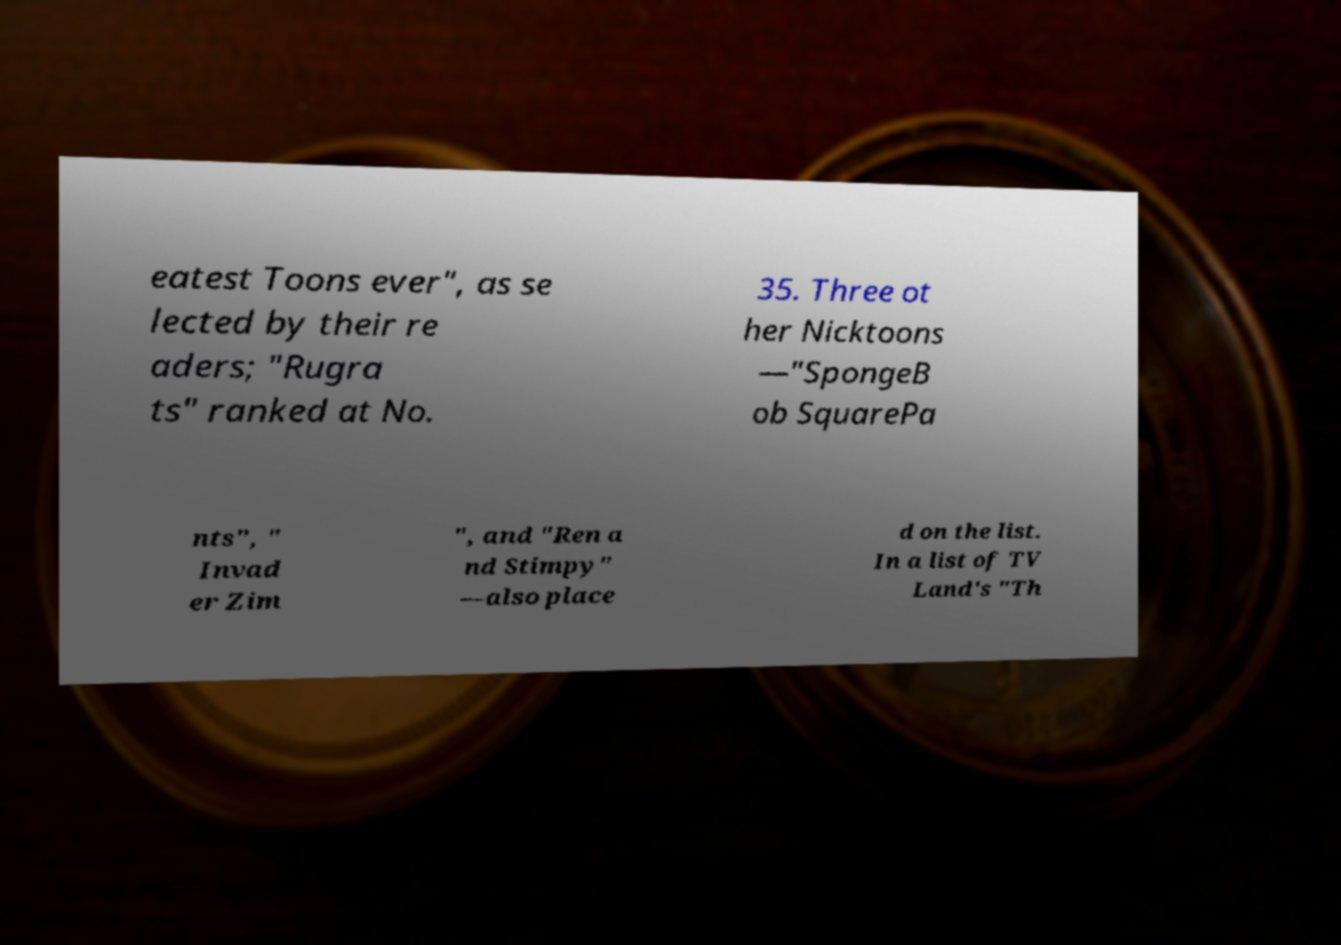Please identify and transcribe the text found in this image. eatest Toons ever", as se lected by their re aders; "Rugra ts" ranked at No. 35. Three ot her Nicktoons —"SpongeB ob SquarePa nts", " Invad er Zim ", and "Ren a nd Stimpy" —also place d on the list. In a list of TV Land's "Th 